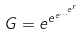Convert formula to latex. <formula><loc_0><loc_0><loc_500><loc_500>G = e ^ { e ^ { e ^ { \dots ^ { e ^ { r } } } } }</formula> 